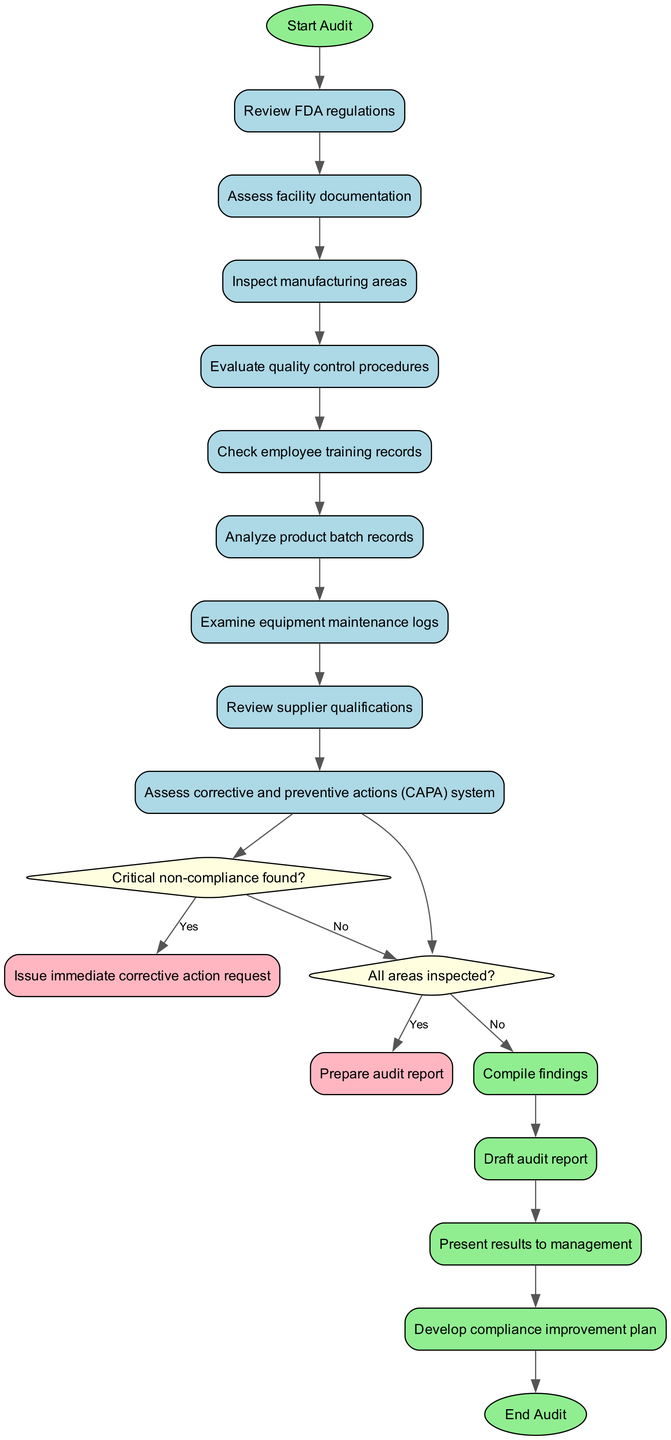What is the initial node labeled as? The diagram starts with the node labeled "Start Audit," which is indicated as the initial node in the data provided.
Answer: Start Audit How many activities are listed in the diagram? There are a total of 9 activities mentioned in the activities list of the diagram, as counted from the data provided.
Answer: 9 What follows after assessing facility documentation? After "Assess facility documentation," the next activity is "Inspect manufacturing areas," which directly follows in the sequence as shown in the diagram structure.
Answer: Inspect manufacturing areas What happens if critical non-compliance is found? If critical non-compliance is found, the diagram indicates to "Issue immediate corrective action request," which is the action specified for that decision point.
Answer: Issue immediate corrective action request Are there any final activities listed in the diagram? Yes, the diagram includes 4 final activities that are performed after the inspection and assessment phases have been completed.
Answer: Yes What is the last activity before the audit ends? The last activity listed before the audit ends is "Develop compliance improvement plan," which precedes the final end node of the audit process in the diagram.
Answer: Develop compliance improvement plan Is there a decision regarding whether all areas have been inspected? Yes, there is a decision node that addresses whether all areas have been inspected, leading to a specific logical flow based on the outcome.
Answer: Yes What type of node is "Review FDA regulations"? "Review FDA regulations" is categorized as an activity node within the diagram, representing a task that must be completed in the audit workflow.
Answer: Activity node Which edge connects the last activity to the first decision node? The edge that connects the last activity, "Examine equipment maintenance logs," to the first decision node, "Critical non-compliance found?", indicates the flow of the auditing process.
Answer: Edge from "Examine equipment maintenance logs" to "Critical non-compliance found?" 